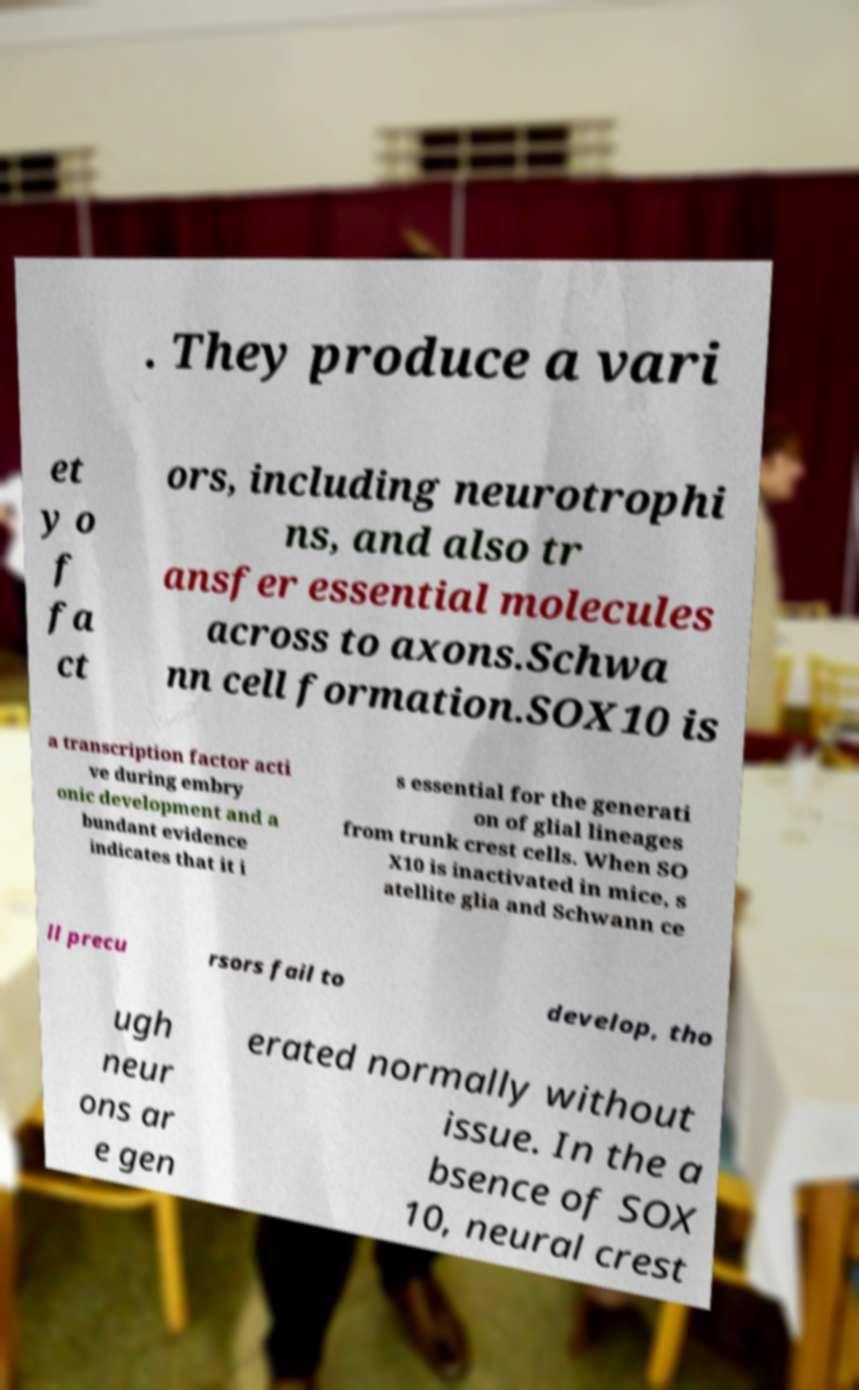Please read and relay the text visible in this image. What does it say? . They produce a vari et y o f fa ct ors, including neurotrophi ns, and also tr ansfer essential molecules across to axons.Schwa nn cell formation.SOX10 is a transcription factor acti ve during embry onic development and a bundant evidence indicates that it i s essential for the generati on of glial lineages from trunk crest cells. When SO X10 is inactivated in mice, s atellite glia and Schwann ce ll precu rsors fail to develop, tho ugh neur ons ar e gen erated normally without issue. In the a bsence of SOX 10, neural crest 